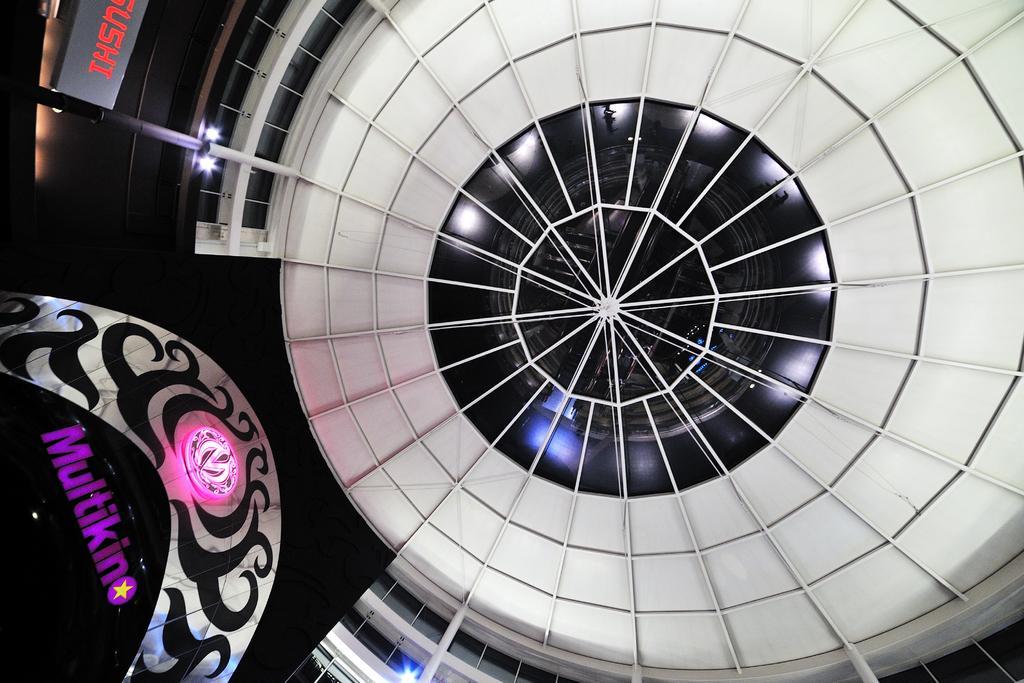Can you describe this image briefly? In this image we can see the roof of the building. There is some text at the left side of the image. 